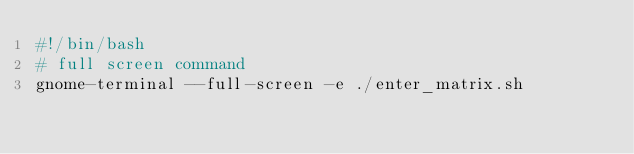<code> <loc_0><loc_0><loc_500><loc_500><_Bash_>#!/bin/bash
# full screen command
gnome-terminal --full-screen -e ./enter_matrix.sh
</code> 